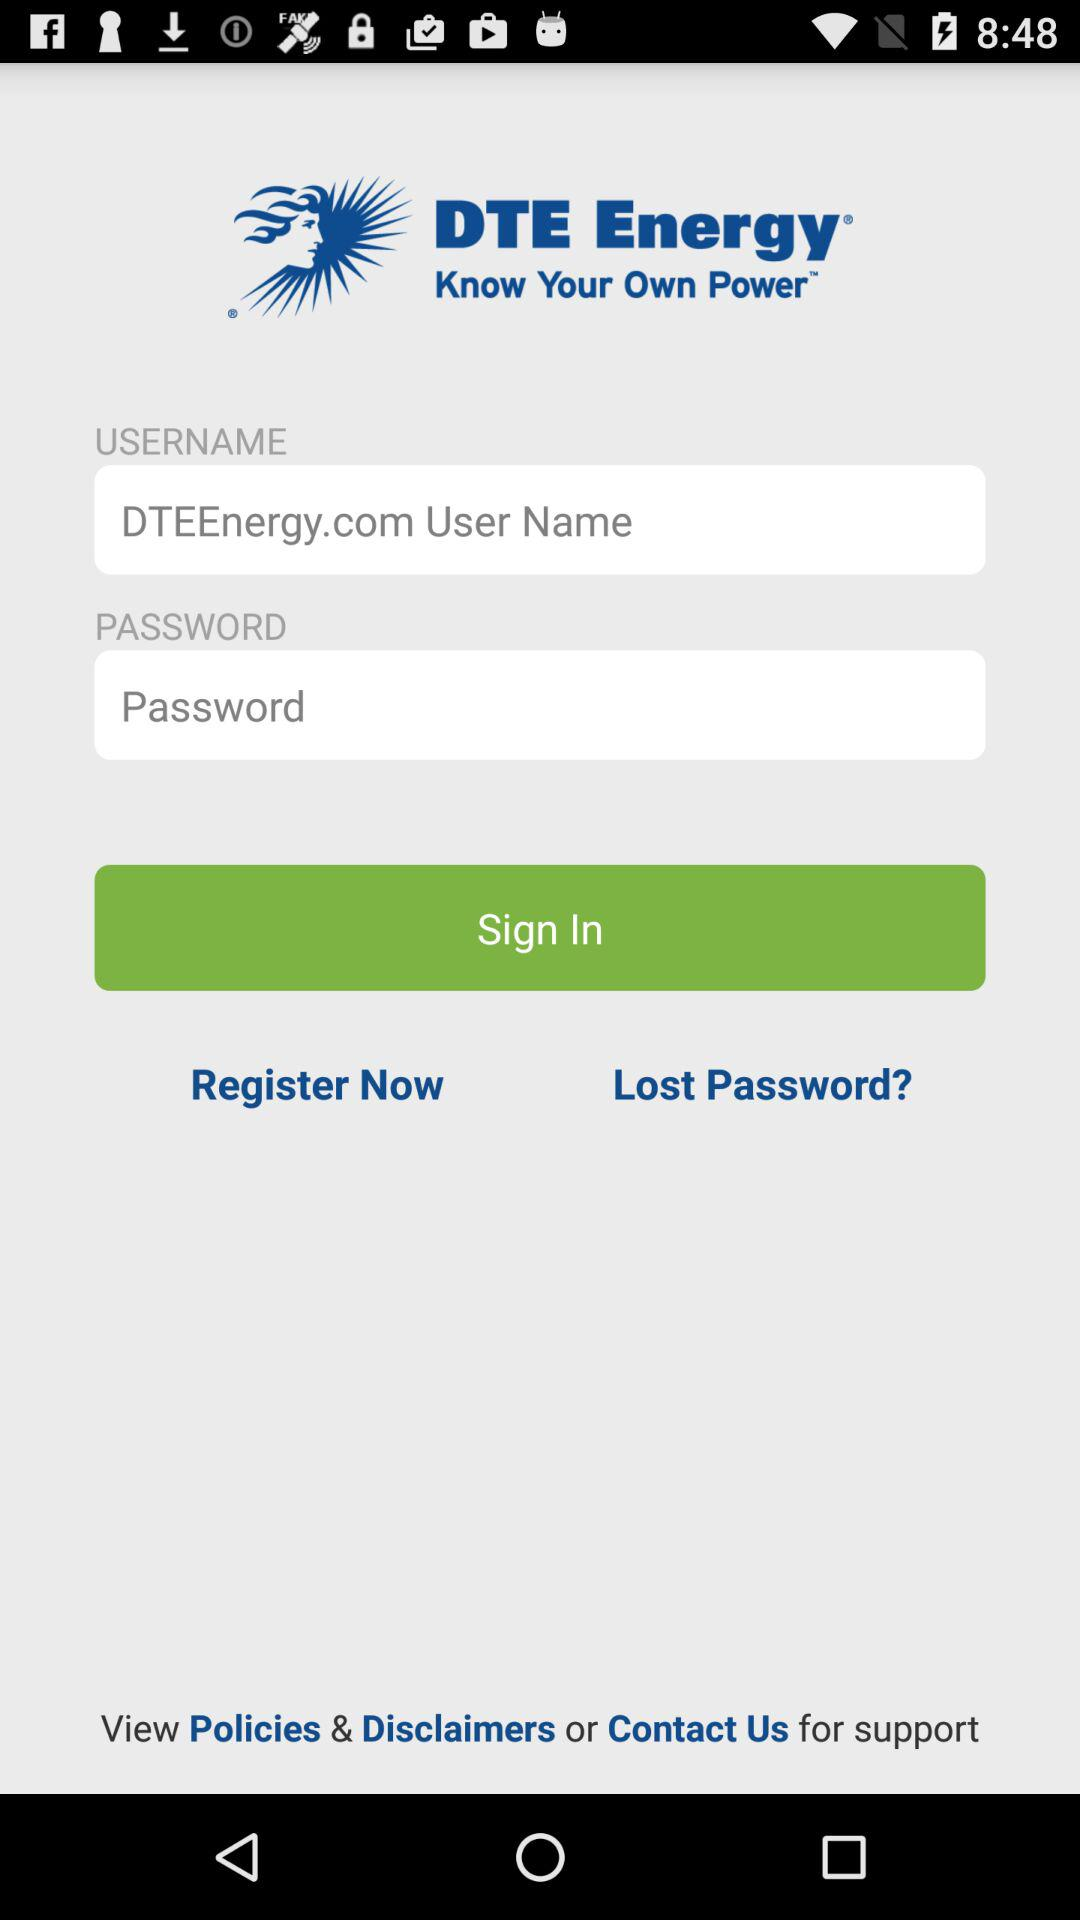How many login fields are there?
Answer the question using a single word or phrase. 2 